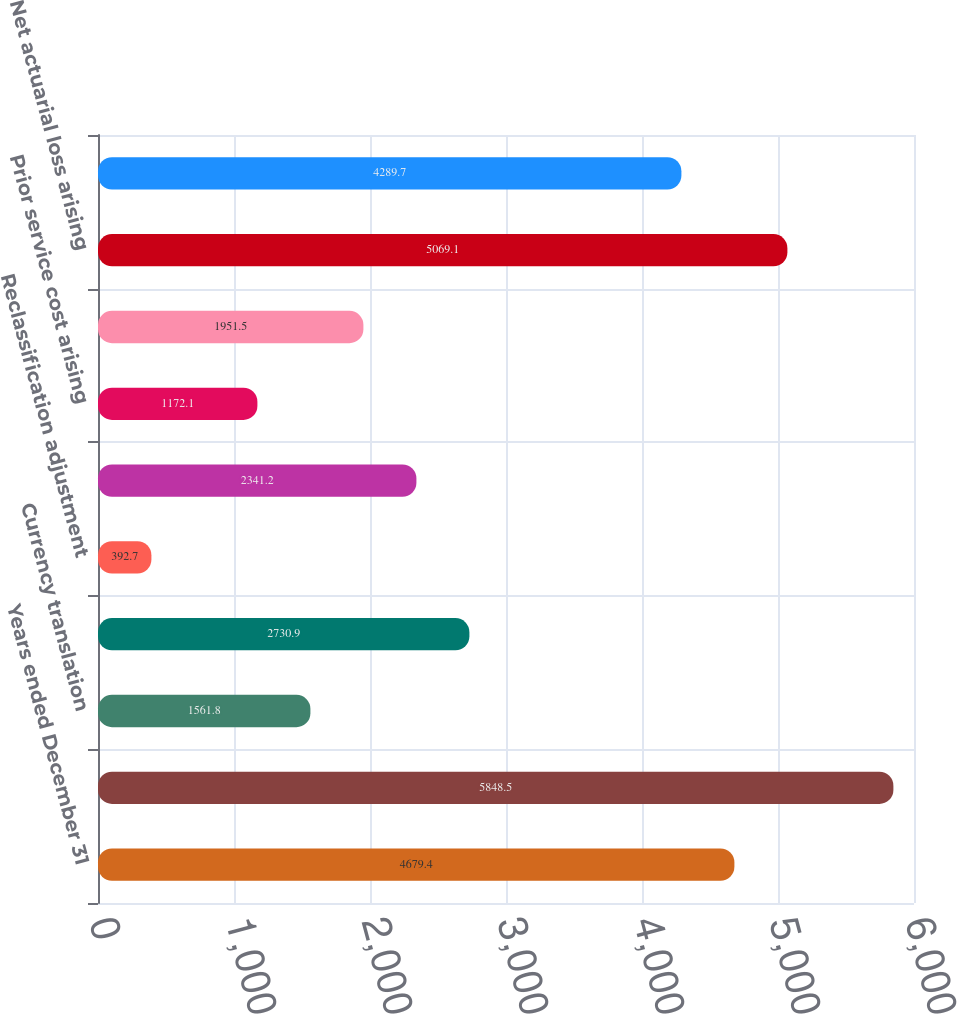Convert chart to OTSL. <chart><loc_0><loc_0><loc_500><loc_500><bar_chart><fcel>Years ended December 31<fcel>Net earnings<fcel>Currency translation<fcel>Unrealized gain/(loss) arising<fcel>Reclassification adjustment<fcel>Total unrealized gain/(loss)<fcel>Prior service cost arising<fcel>Amortization of prior service<fcel>Net actuarial loss arising<fcel>Amortization of actuarial<nl><fcel>4679.4<fcel>5848.5<fcel>1561.8<fcel>2730.9<fcel>392.7<fcel>2341.2<fcel>1172.1<fcel>1951.5<fcel>5069.1<fcel>4289.7<nl></chart> 